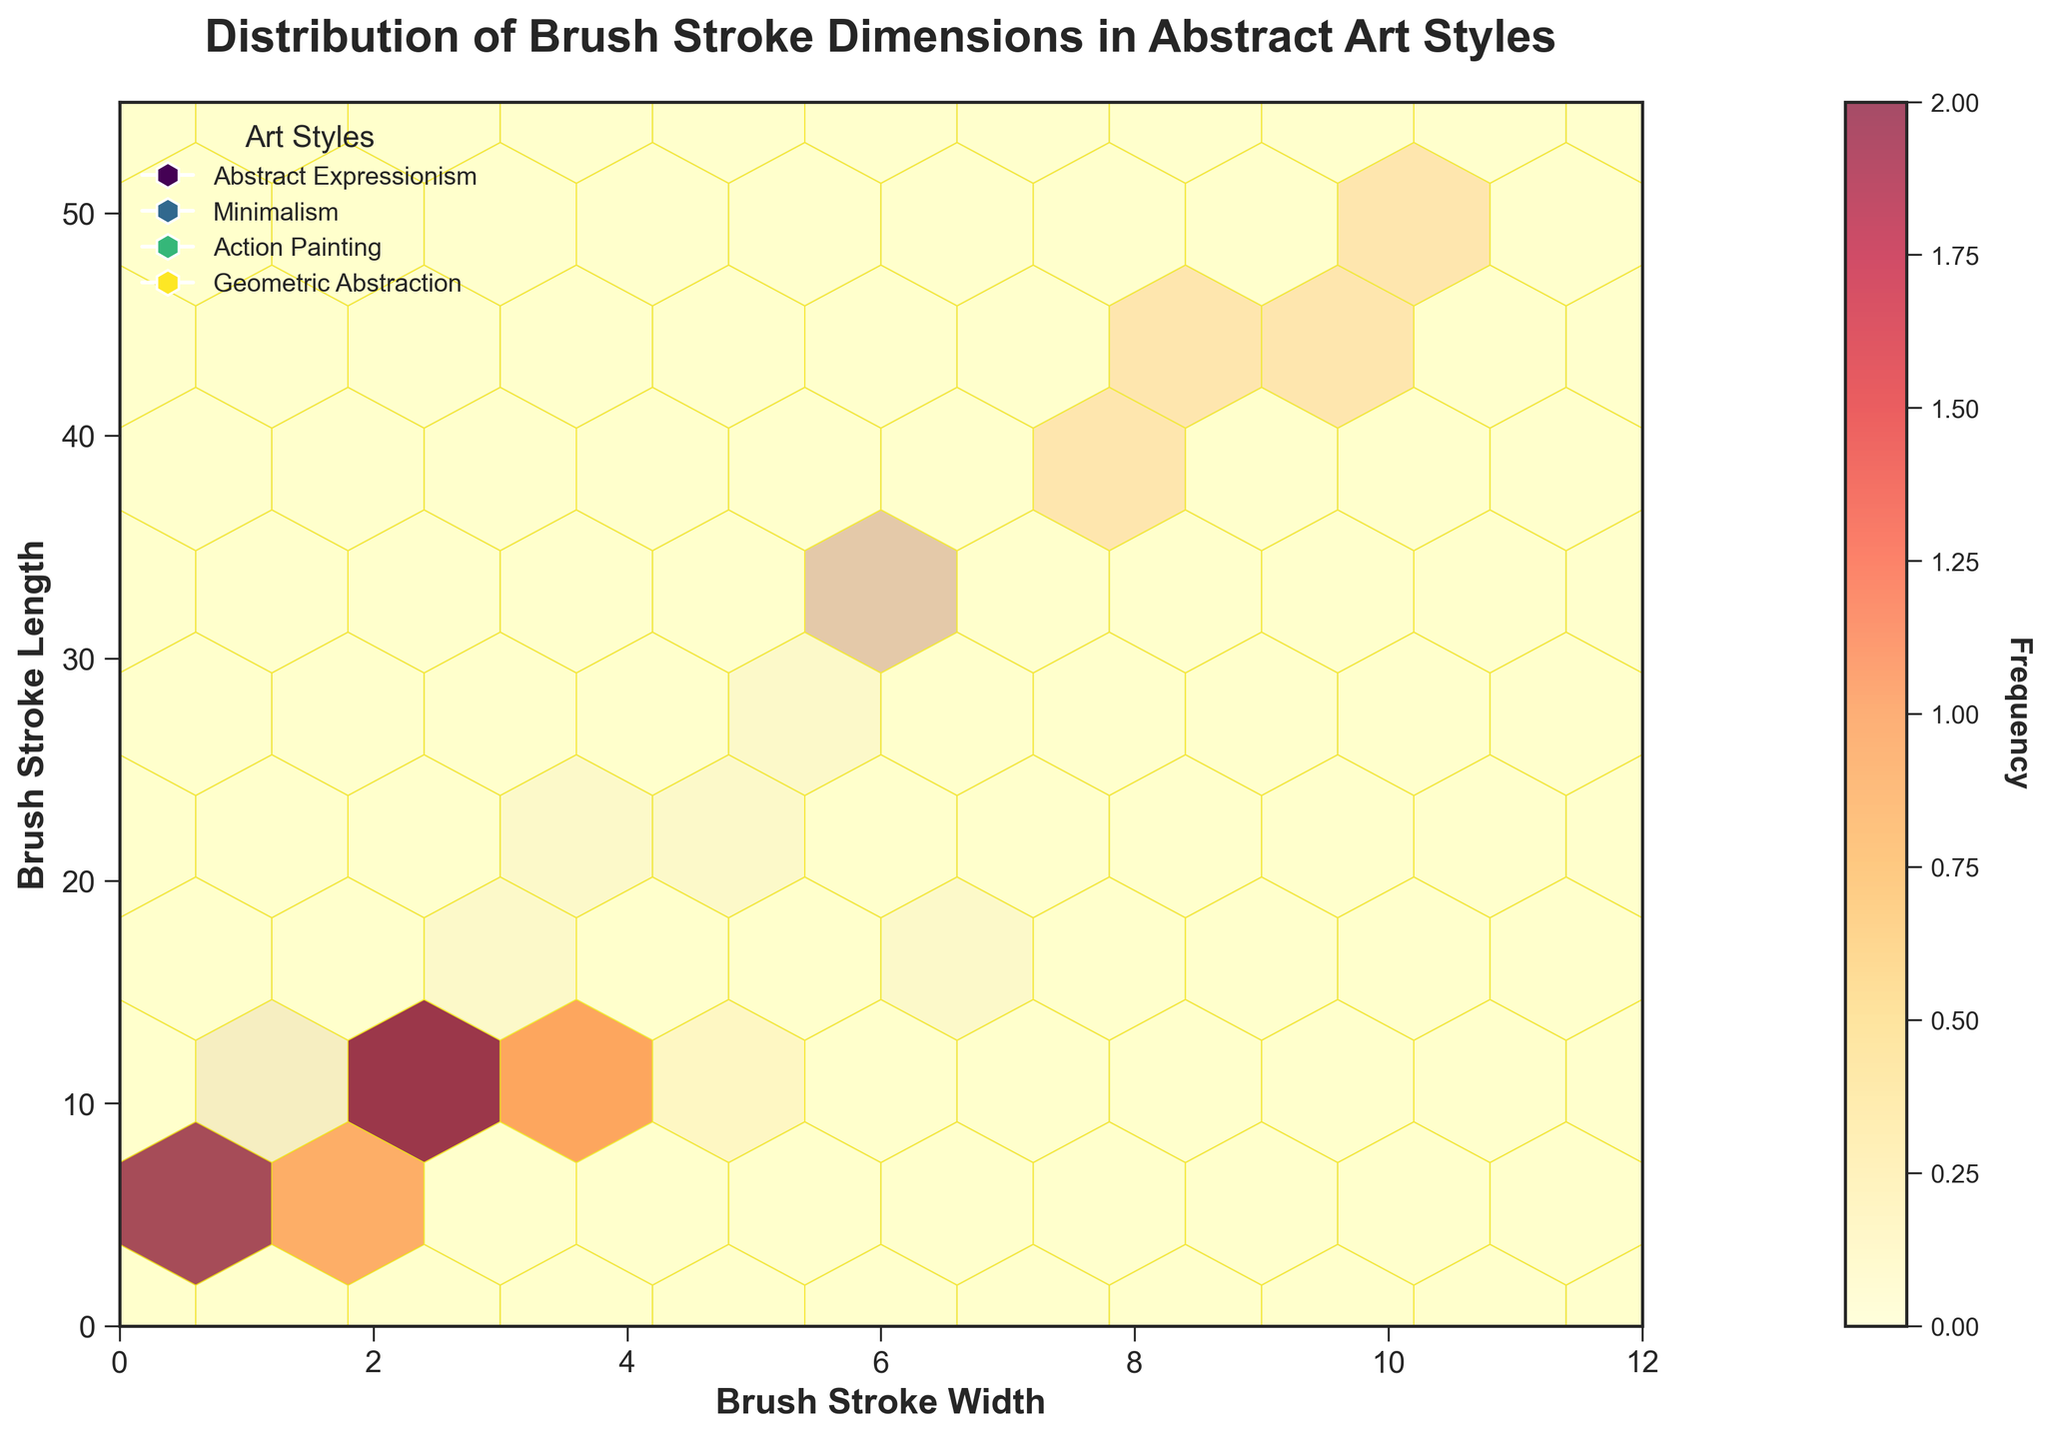What's the title of the plot? The title is located at the top of the figure and summarizes what the plot represents. In this case, it reads "Distribution of Brush Stroke Dimensions in Abstract Art Styles."
Answer: Distribution of Brush Stroke Dimensions in Abstract Art Styles What are the labels on the X and Y axes? The X-axis represents "Brush Stroke Width," and the Y-axis represents "Brush Stroke Length." These labels are written along each axis to describe the data they portray.
Answer: Brush Stroke Width, Brush Stroke Length Which abstract art style has the most extended brush strokes? By examining the distribution of brush strokes along the Y-axis, "Action Painting" has the highest values reaching up to 50, indicating the longest brush strokes.
Answer: Action Painting Which style has the highest frequency of brush strokes with lengths between 40 and 50? The highest frequency for brush strokes in this range can be observed by the density of hexagons colored in deeper shades in the Y-axis range from 40 to 50. "Action Painting" shows the highest density here.
Answer: Action Painting How does the brush stroke length of Minimalism compare to that of Abstract Expressionism? Minimalism features brush strokes with lengths predominantly in the lower range (8-14), while Abstract Expressionism has a broader range and higher lengths (up to 30). The difference indicates that Abstract Expressionism brush strokes tend to be longer.
Answer: Abstract Expressionism has longer brush strokes Is there any art style with brush stroke widths primarily below 2? By looking at the distributions on the X-axis, "Geometric Abstraction" has brush strokes with widths predominantly below 2.
Answer: Geometric Abstraction What is the average brush stroke length for Action Painting? For Action Painting, adding the lengths (35 + 42 + 50 + 38 + 45 + 32) and dividing by the number of data points (6) gives an average (242/6).
Answer: 40.33 Which style has the least variation in brush stroke width? Minimalism shows brush strokes that are more closely clustered in width values (approximately 1.2 to 4.8), whereas other styles have more spread out values, indicating minimal variation in widths.
Answer: Minimalism How do the brush stroke lengths of Geometric Abstraction compare to Minimalism? Geometric Abstraction has lengths between 5 to 11, whereas Minimalism has lengths ranging from 8 to 14. The lengths in Minimalism are slightly higher and less varied.
Answer: Minimalism has slightly higher lengths 